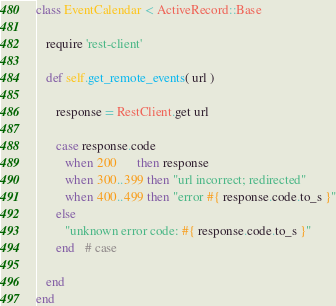<code> <loc_0><loc_0><loc_500><loc_500><_Ruby_>class EventCalendar < ActiveRecord::Base

   require 'rest-client'

   def self.get_remote_events( url )

      response = RestClient.get url

      case response.code
         when 200      then response
         when 300..399 then "url incorrect; redirected"
         when 400..499 then "error #{ response.code.to_s }"
      else
         "unknown error code: #{ response.code.to_s }"
      end   # case

   end
end
</code> 